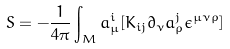<formula> <loc_0><loc_0><loc_500><loc_500>S = - \frac { 1 } { 4 \pi } \int _ { M } a _ { \mu } ^ { i } [ K _ { i j } \partial _ { \nu } a _ { \rho } ^ { j } \epsilon ^ { \mu \nu \rho } ]</formula> 